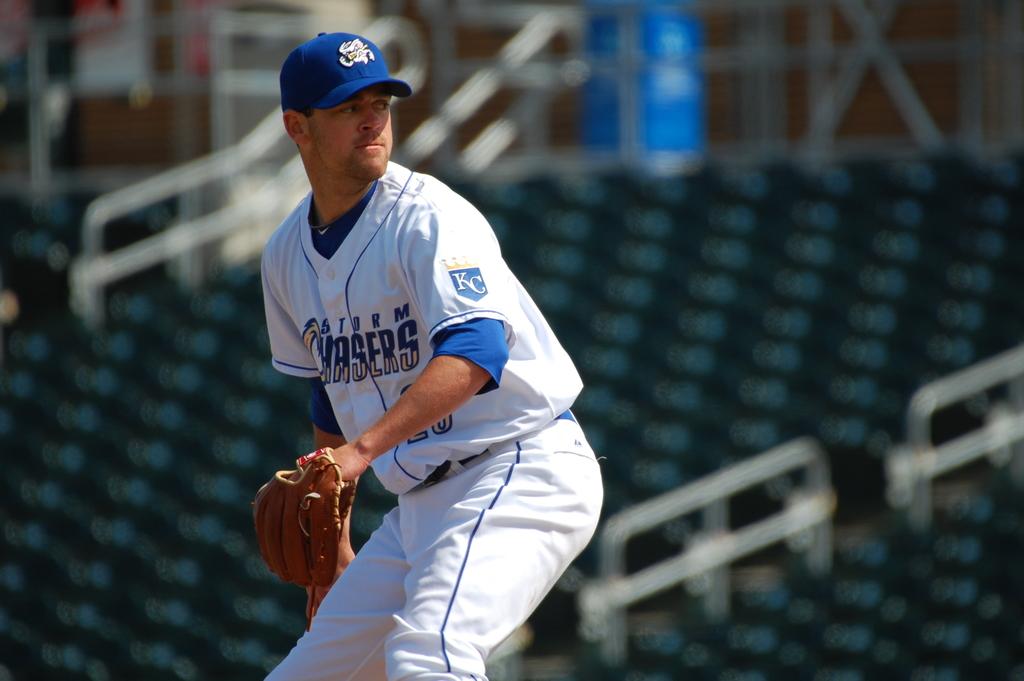What is the minor league baseball team in nebraska?
Provide a succinct answer. Storm chasers. What letters are on his sleeve?
Your response must be concise. Kc. 